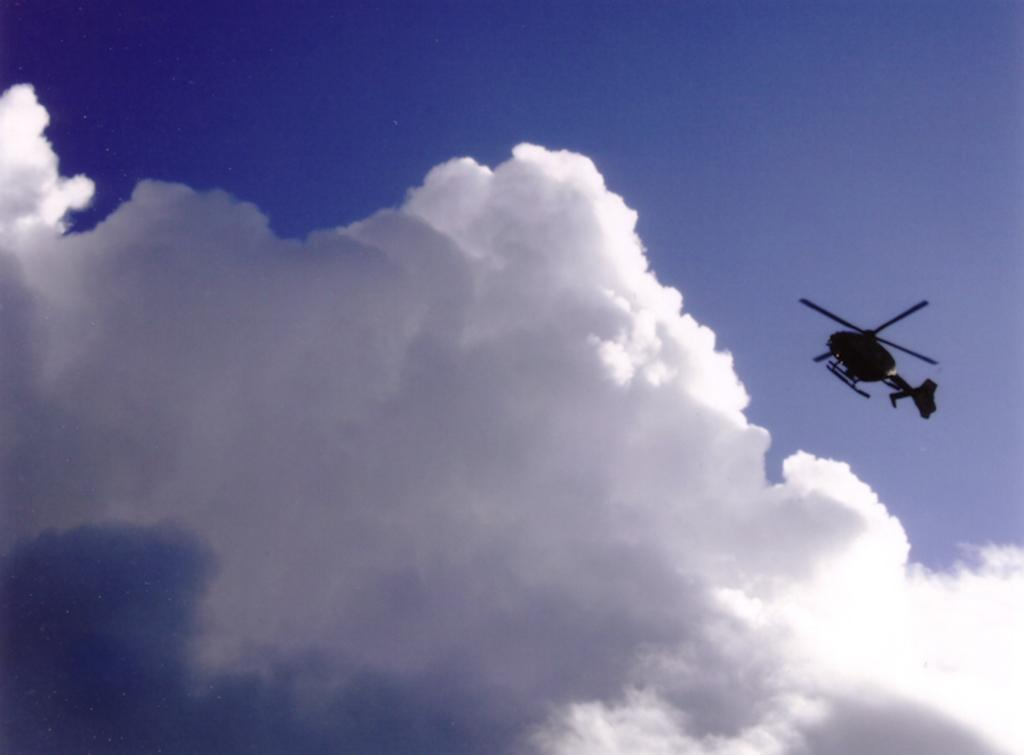What is the main subject of the image? The main subject of the image is a helicopter. What is the helicopter doing in the image? The helicopter is flying in the air. What can be seen in the sky in the image? The sky is visible in the image, and there are clouds in the sky. What type of plant can be seen growing on the helicopter in the image? There is no plant growing on the helicopter in the image. What color is the crayon being used to draw on the helicopter in the image? There is no crayon or drawing activity present in the image. 